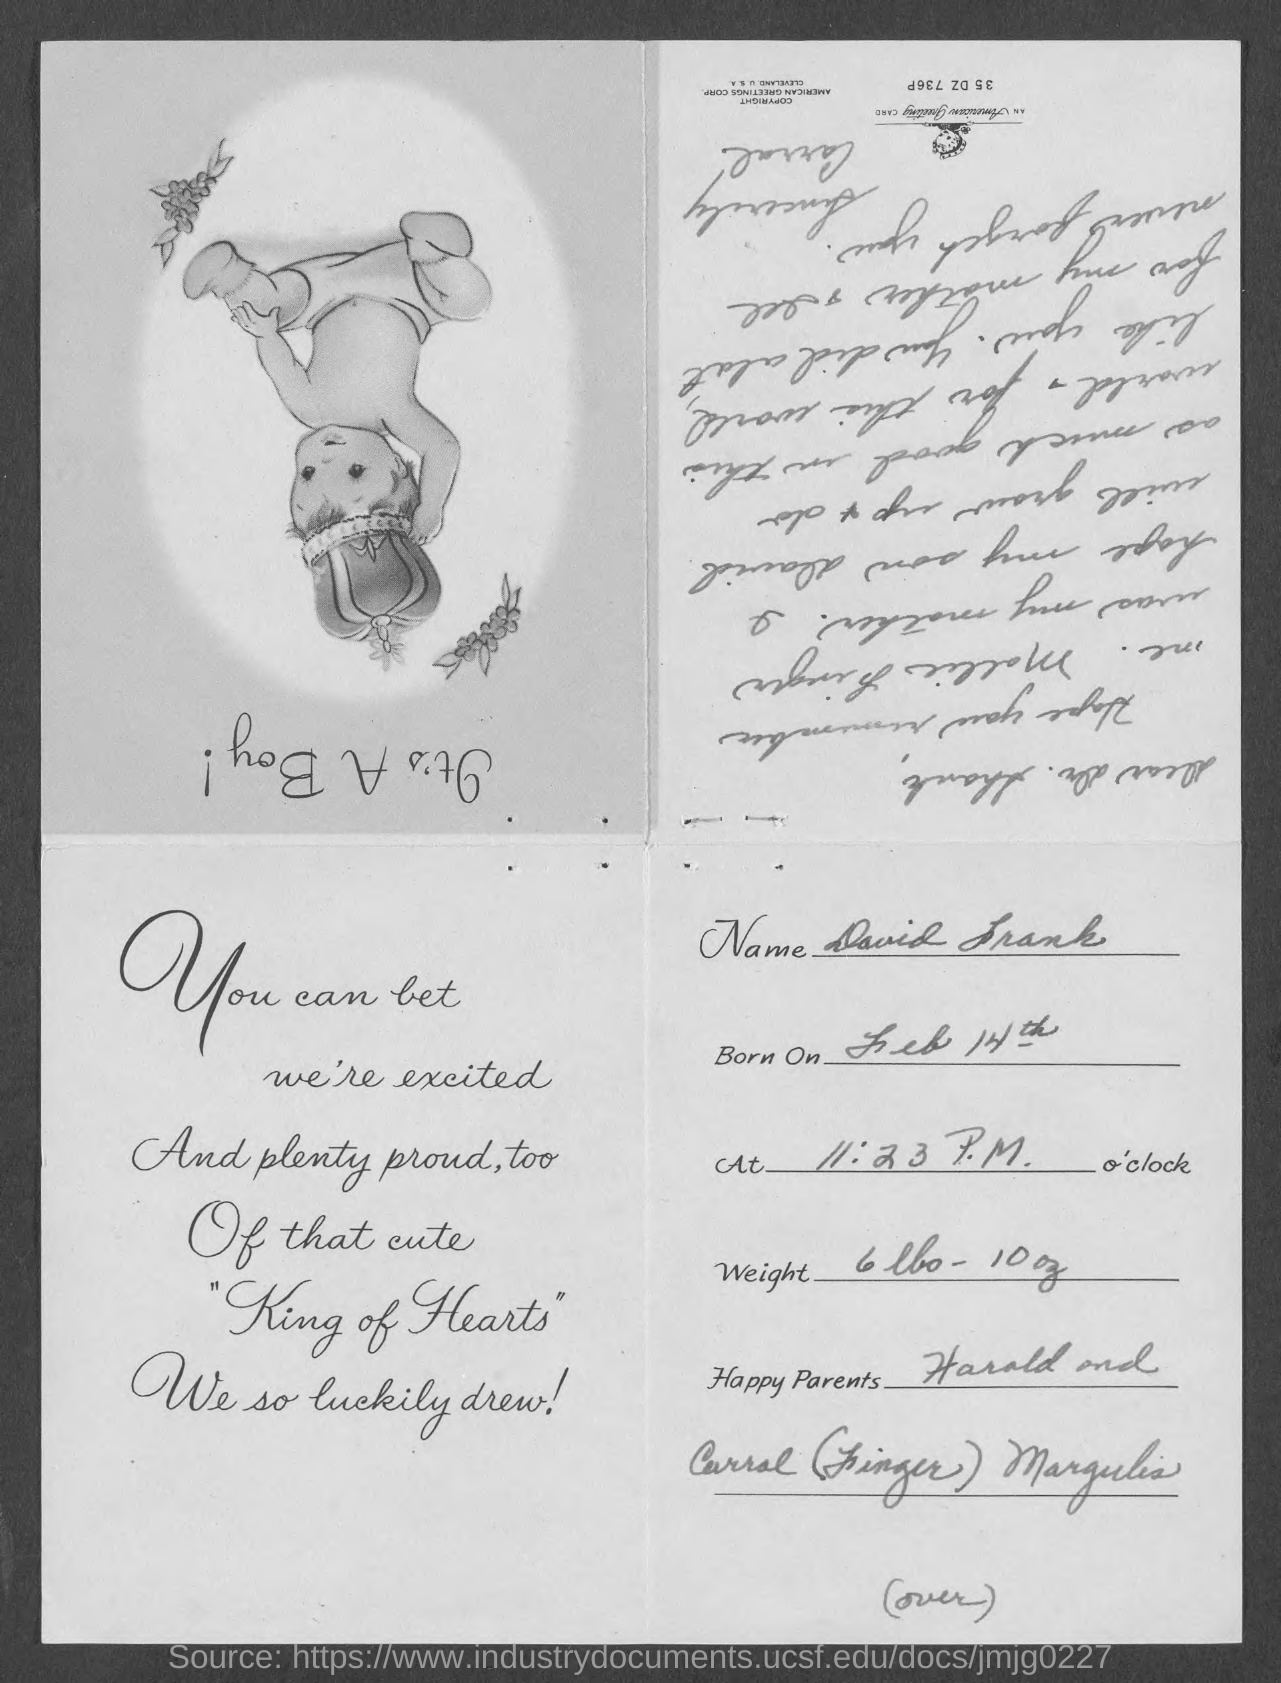Draw attention to some important aspects in this diagram. The weight is 6 pounds and 10 ounces. He was born on February 14th. The name is David Frank. 